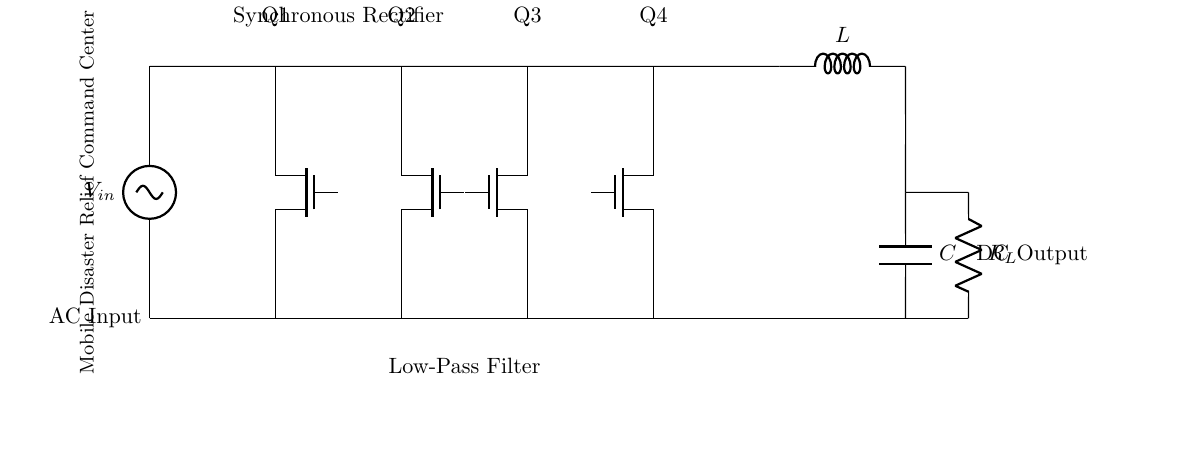What is the type of rectifier used in this circuit? The circuit employs a synchronous rectifier, as indicated by the labeled components Q1, Q2, Q3, and Q4, which are all transistors used for rectification.
Answer: synchronous rectifier How many transistors are present in the circuit? There are four transistors (Q1, Q2, Q3, Q4) shown in the diagram, serving as the main switching elements of the synchronous rectifier.
Answer: four What component filters the output in this circuit? The component that filters the output is a capacitor, labeled as C, which smooths the rectified voltage at the output.
Answer: capacitor What provides the inductor function in this circuit? The inductor is indicated as L in the diagram, which helps in smoothing the current and reducing fluctuations in the output voltage.
Answer: inductor What is the label for the DC output? The label for the DC output is shown as "DC Output" in the schematic, identifying the voltage supplied to the load after rectification and filtering.
Answer: DC Output Why are low-resistance paths needed for transistors in this rectifier? Low-resistance paths for transistors allow for efficient conduction of current during the switching operation, reducing power losses and improving overall efficiency in power conversion.
Answer: efficient conduction What is the purpose of the load resistor in this circuit? The load resistor, labeled as R_L, dissipates power and represents the load the rectifier drives, providing a means of extracting the output power to be used.
Answer: load resistor 